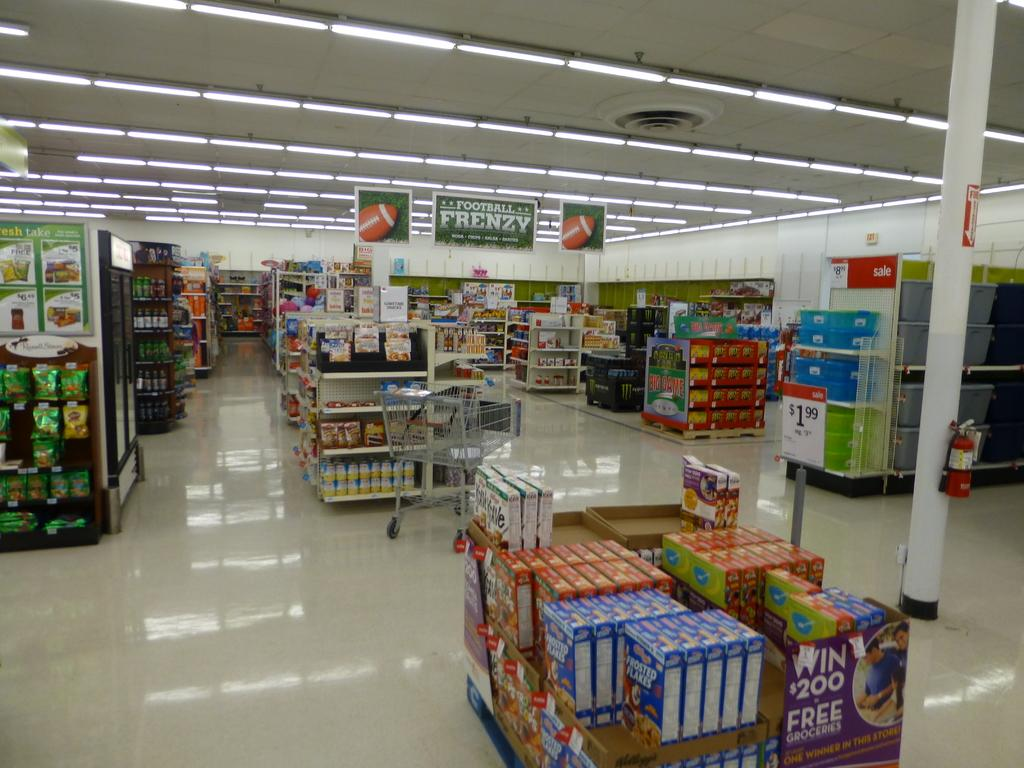<image>
Write a terse but informative summary of the picture. Win $200 Free box in a supermarket next to some Frosted Flakes. 